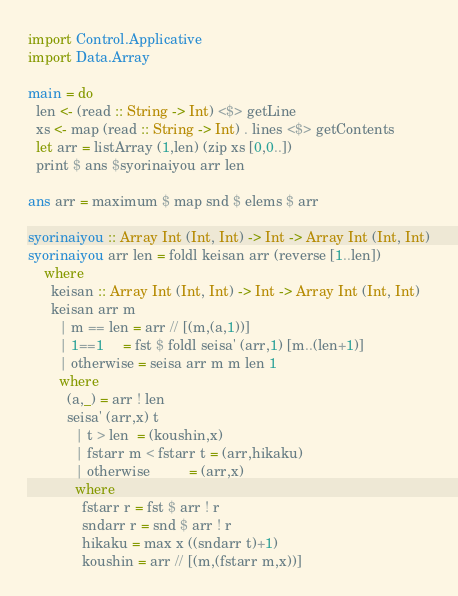Convert code to text. <code><loc_0><loc_0><loc_500><loc_500><_Haskell_>import Control.Applicative
import Data.Array

main = do
  len <- (read :: String -> Int) <$> getLine
  xs <- map (read :: String -> Int) . lines <$> getContents
  let arr = listArray (1,len) (zip xs [0,0..])
  print $ ans $syorinaiyou arr len

ans arr = maximum $ map snd $ elems $ arr

syorinaiyou :: Array Int (Int, Int) -> Int -> Array Int (Int, Int)
syorinaiyou arr len = foldl keisan arr (reverse [1..len])
    where
      keisan :: Array Int (Int, Int) -> Int -> Array Int (Int, Int)
      keisan arr m
        | m == len = arr // [(m,(a,1))]
        | 1==1     = fst $ foldl seisa' (arr,1) [m..(len+1)]
        | otherwise = seisa arr m m len 1
        where
          (a,_) = arr ! len
          seisa' (arr,x) t
            | t > len  = (koushin,x)
            | fstarr m < fstarr t = (arr,hikaku)
            | otherwise          = (arr,x)
            where
              fstarr r = fst $ arr ! r
              sndarr r = snd $ arr ! r
              hikaku = max x ((sndarr t)+1)
              koushin = arr // [(m,(fstarr m,x))]</code> 